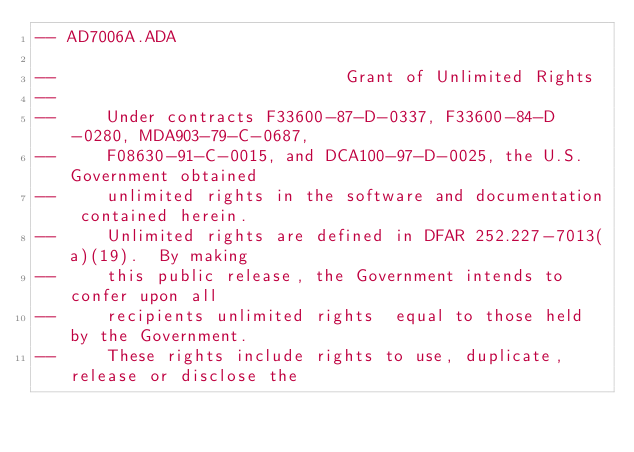<code> <loc_0><loc_0><loc_500><loc_500><_Ada_>-- AD7006A.ADA

--                             Grant of Unlimited Rights
--
--     Under contracts F33600-87-D-0337, F33600-84-D-0280, MDA903-79-C-0687,
--     F08630-91-C-0015, and DCA100-97-D-0025, the U.S. Government obtained 
--     unlimited rights in the software and documentation contained herein.
--     Unlimited rights are defined in DFAR 252.227-7013(a)(19).  By making 
--     this public release, the Government intends to confer upon all 
--     recipients unlimited rights  equal to those held by the Government.  
--     These rights include rights to use, duplicate, release or disclose the </code> 